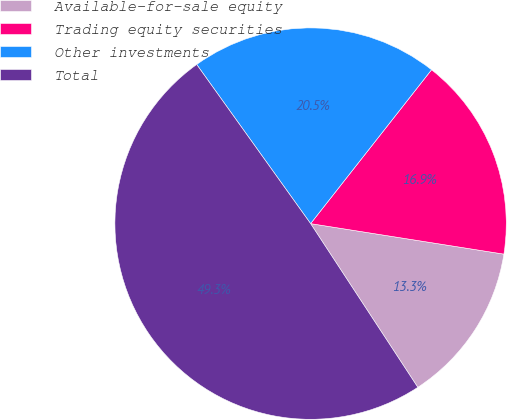<chart> <loc_0><loc_0><loc_500><loc_500><pie_chart><fcel>Available-for-sale equity<fcel>Trading equity securities<fcel>Other investments<fcel>Total<nl><fcel>13.28%<fcel>16.89%<fcel>20.49%<fcel>49.34%<nl></chart> 